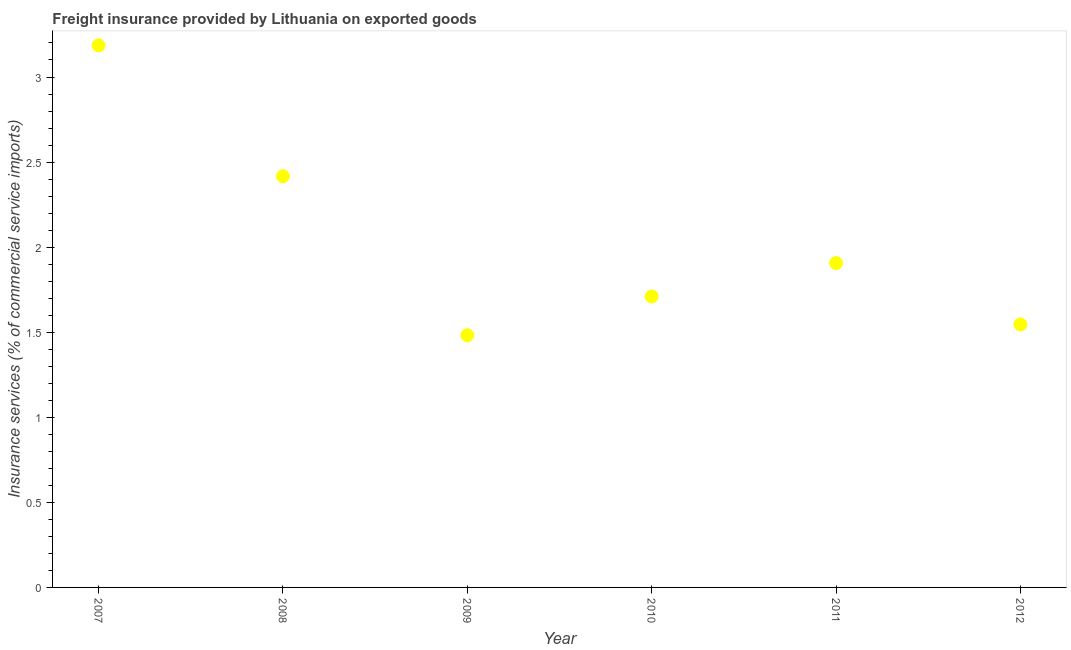What is the freight insurance in 2011?
Your answer should be very brief. 1.91. Across all years, what is the maximum freight insurance?
Provide a succinct answer. 3.19. Across all years, what is the minimum freight insurance?
Keep it short and to the point. 1.48. In which year was the freight insurance maximum?
Make the answer very short. 2007. In which year was the freight insurance minimum?
Keep it short and to the point. 2009. What is the sum of the freight insurance?
Give a very brief answer. 12.25. What is the difference between the freight insurance in 2007 and 2012?
Your response must be concise. 1.64. What is the average freight insurance per year?
Keep it short and to the point. 2.04. What is the median freight insurance?
Offer a terse response. 1.81. Do a majority of the years between 2009 and 2012 (inclusive) have freight insurance greater than 0.8 %?
Make the answer very short. Yes. What is the ratio of the freight insurance in 2011 to that in 2012?
Ensure brevity in your answer.  1.23. Is the freight insurance in 2007 less than that in 2011?
Offer a terse response. No. Is the difference between the freight insurance in 2007 and 2008 greater than the difference between any two years?
Provide a succinct answer. No. What is the difference between the highest and the second highest freight insurance?
Make the answer very short. 0.77. What is the difference between the highest and the lowest freight insurance?
Your answer should be very brief. 1.7. In how many years, is the freight insurance greater than the average freight insurance taken over all years?
Make the answer very short. 2. Does the freight insurance monotonically increase over the years?
Your answer should be compact. No. How many dotlines are there?
Keep it short and to the point. 1. How many years are there in the graph?
Ensure brevity in your answer.  6. What is the difference between two consecutive major ticks on the Y-axis?
Your answer should be compact. 0.5. Are the values on the major ticks of Y-axis written in scientific E-notation?
Offer a terse response. No. What is the title of the graph?
Make the answer very short. Freight insurance provided by Lithuania on exported goods . What is the label or title of the X-axis?
Give a very brief answer. Year. What is the label or title of the Y-axis?
Your response must be concise. Insurance services (% of commercial service imports). What is the Insurance services (% of commercial service imports) in 2007?
Provide a short and direct response. 3.19. What is the Insurance services (% of commercial service imports) in 2008?
Provide a short and direct response. 2.42. What is the Insurance services (% of commercial service imports) in 2009?
Keep it short and to the point. 1.48. What is the Insurance services (% of commercial service imports) in 2010?
Offer a very short reply. 1.71. What is the Insurance services (% of commercial service imports) in 2011?
Keep it short and to the point. 1.91. What is the Insurance services (% of commercial service imports) in 2012?
Ensure brevity in your answer.  1.55. What is the difference between the Insurance services (% of commercial service imports) in 2007 and 2008?
Your response must be concise. 0.77. What is the difference between the Insurance services (% of commercial service imports) in 2007 and 2009?
Make the answer very short. 1.7. What is the difference between the Insurance services (% of commercial service imports) in 2007 and 2010?
Your answer should be compact. 1.48. What is the difference between the Insurance services (% of commercial service imports) in 2007 and 2011?
Keep it short and to the point. 1.28. What is the difference between the Insurance services (% of commercial service imports) in 2007 and 2012?
Your response must be concise. 1.64. What is the difference between the Insurance services (% of commercial service imports) in 2008 and 2009?
Ensure brevity in your answer.  0.93. What is the difference between the Insurance services (% of commercial service imports) in 2008 and 2010?
Your answer should be very brief. 0.71. What is the difference between the Insurance services (% of commercial service imports) in 2008 and 2011?
Your answer should be very brief. 0.51. What is the difference between the Insurance services (% of commercial service imports) in 2008 and 2012?
Ensure brevity in your answer.  0.87. What is the difference between the Insurance services (% of commercial service imports) in 2009 and 2010?
Your answer should be very brief. -0.23. What is the difference between the Insurance services (% of commercial service imports) in 2009 and 2011?
Your answer should be compact. -0.42. What is the difference between the Insurance services (% of commercial service imports) in 2009 and 2012?
Offer a very short reply. -0.06. What is the difference between the Insurance services (% of commercial service imports) in 2010 and 2011?
Your response must be concise. -0.2. What is the difference between the Insurance services (% of commercial service imports) in 2010 and 2012?
Your answer should be compact. 0.16. What is the difference between the Insurance services (% of commercial service imports) in 2011 and 2012?
Offer a very short reply. 0.36. What is the ratio of the Insurance services (% of commercial service imports) in 2007 to that in 2008?
Your answer should be compact. 1.32. What is the ratio of the Insurance services (% of commercial service imports) in 2007 to that in 2009?
Your answer should be compact. 2.15. What is the ratio of the Insurance services (% of commercial service imports) in 2007 to that in 2010?
Provide a succinct answer. 1.86. What is the ratio of the Insurance services (% of commercial service imports) in 2007 to that in 2011?
Provide a succinct answer. 1.67. What is the ratio of the Insurance services (% of commercial service imports) in 2007 to that in 2012?
Make the answer very short. 2.06. What is the ratio of the Insurance services (% of commercial service imports) in 2008 to that in 2009?
Your response must be concise. 1.63. What is the ratio of the Insurance services (% of commercial service imports) in 2008 to that in 2010?
Your response must be concise. 1.41. What is the ratio of the Insurance services (% of commercial service imports) in 2008 to that in 2011?
Your answer should be very brief. 1.27. What is the ratio of the Insurance services (% of commercial service imports) in 2008 to that in 2012?
Provide a short and direct response. 1.56. What is the ratio of the Insurance services (% of commercial service imports) in 2009 to that in 2010?
Your response must be concise. 0.87. What is the ratio of the Insurance services (% of commercial service imports) in 2009 to that in 2011?
Your answer should be very brief. 0.78. What is the ratio of the Insurance services (% of commercial service imports) in 2010 to that in 2011?
Your answer should be very brief. 0.9. What is the ratio of the Insurance services (% of commercial service imports) in 2010 to that in 2012?
Your response must be concise. 1.11. What is the ratio of the Insurance services (% of commercial service imports) in 2011 to that in 2012?
Your answer should be compact. 1.23. 